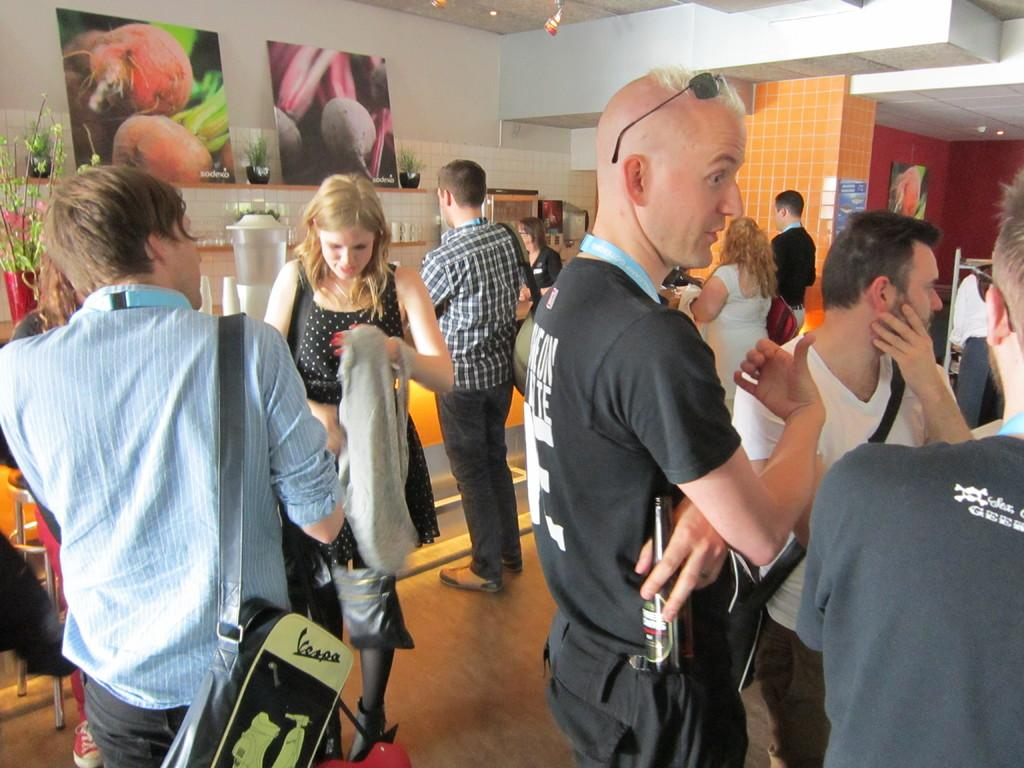How many people are present in the image? There are many people in the image. What are the people doing in the image? The people are carrying objects. What type of artwork can be seen in the image? There are paintings in the image. How many objects are present in the image? There are few objects in the image. What can be used for illumination in the image? There are lights in the image. How many centimeters is the kettle in the image? There is no kettle present in the image, so it is not possible to determine its size in centimeters. 